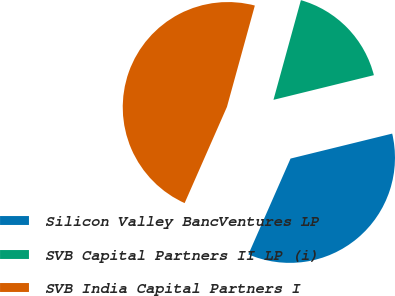Convert chart. <chart><loc_0><loc_0><loc_500><loc_500><pie_chart><fcel>Silicon Valley BancVentures LP<fcel>SVB Capital Partners II LP (i)<fcel>SVB India Capital Partners I<nl><fcel>35.43%<fcel>16.89%<fcel>47.68%<nl></chart> 